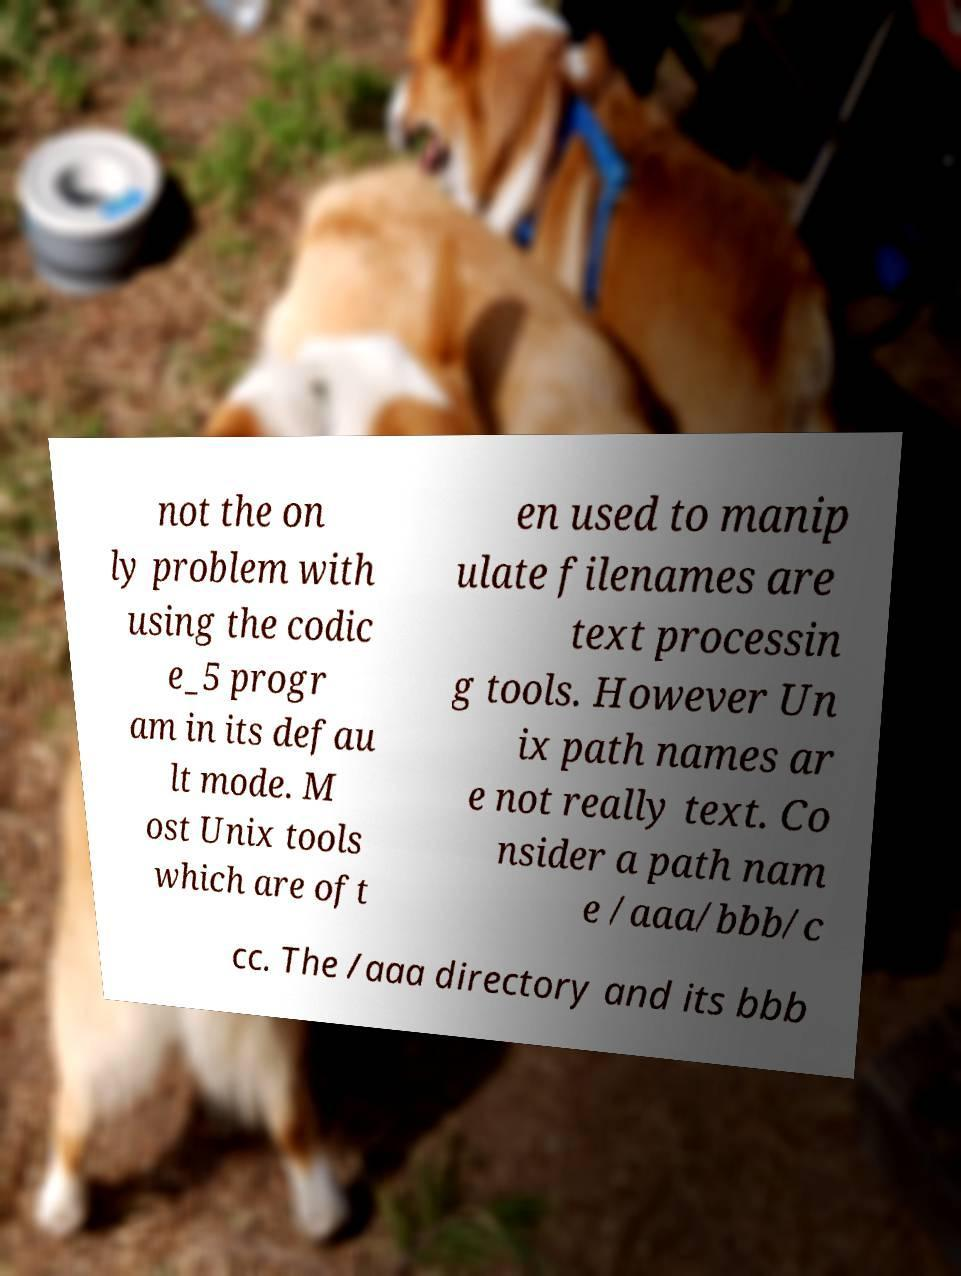For documentation purposes, I need the text within this image transcribed. Could you provide that? not the on ly problem with using the codic e_5 progr am in its defau lt mode. M ost Unix tools which are oft en used to manip ulate filenames are text processin g tools. However Un ix path names ar e not really text. Co nsider a path nam e /aaa/bbb/c cc. The /aaa directory and its bbb 